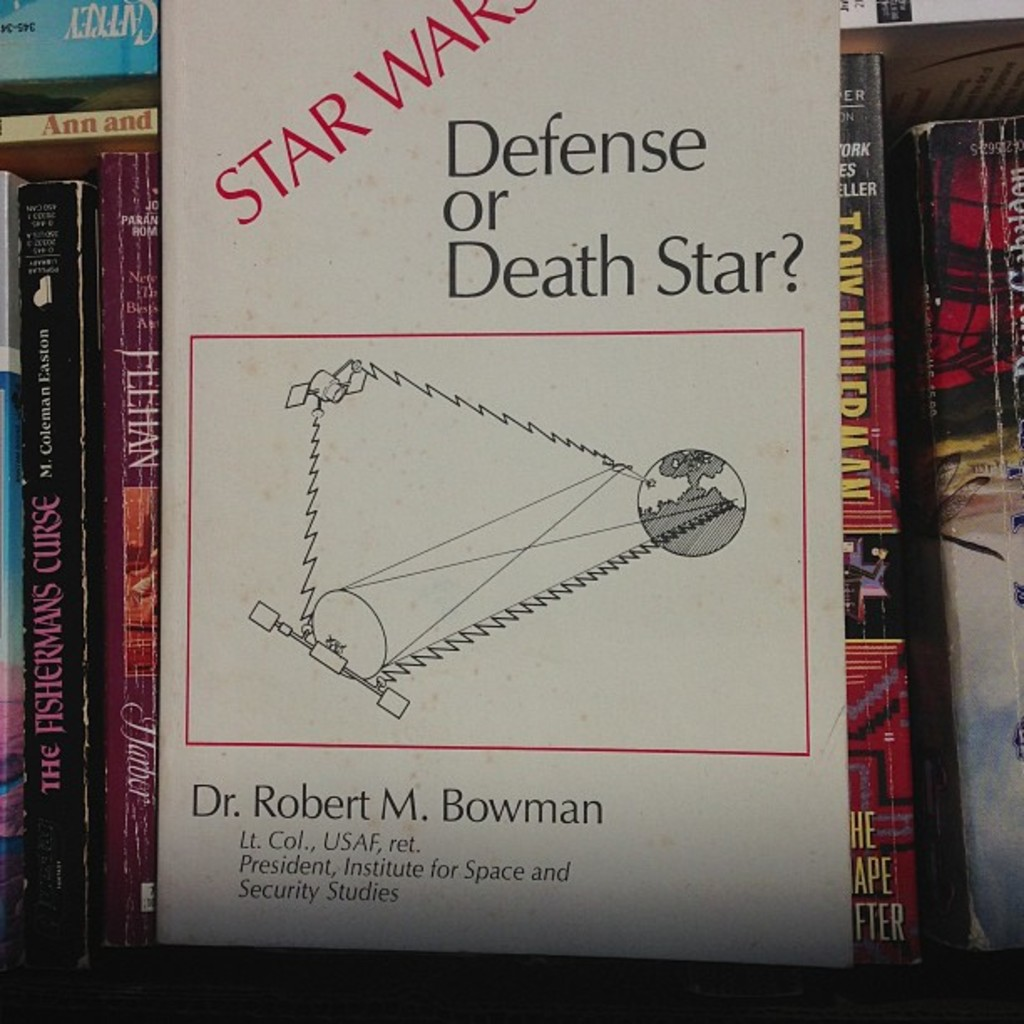What can you tell me about the author mentioned on the book cover? Dr. Robert M. Bowman, highlighted on the cover as the author, is recognized as a retired Lieutenant Colonel from the United States Air Force. His credentials include serving as the President of the Institute for Space and Security Studies. He's notable for his expertise and viewpoints on national security and space technology, which likely fuel the insights shared within his book on the intersection of popular culture's depiction of space combat and real-world military strategies. 